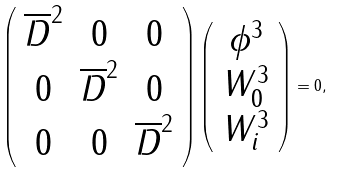Convert formula to latex. <formula><loc_0><loc_0><loc_500><loc_500>\left ( \begin{array} { c c c } \overline { D } ^ { 2 } & 0 & 0 \\ 0 & \overline { D } ^ { 2 } & 0 \\ 0 & 0 & \overline { D } ^ { 2 } \end{array} \right ) \left ( \begin{array} { c } \phi ^ { 3 } \\ W _ { 0 } ^ { 3 } \\ W _ { i } ^ { 3 } \end{array} \right ) = 0 ,</formula> 